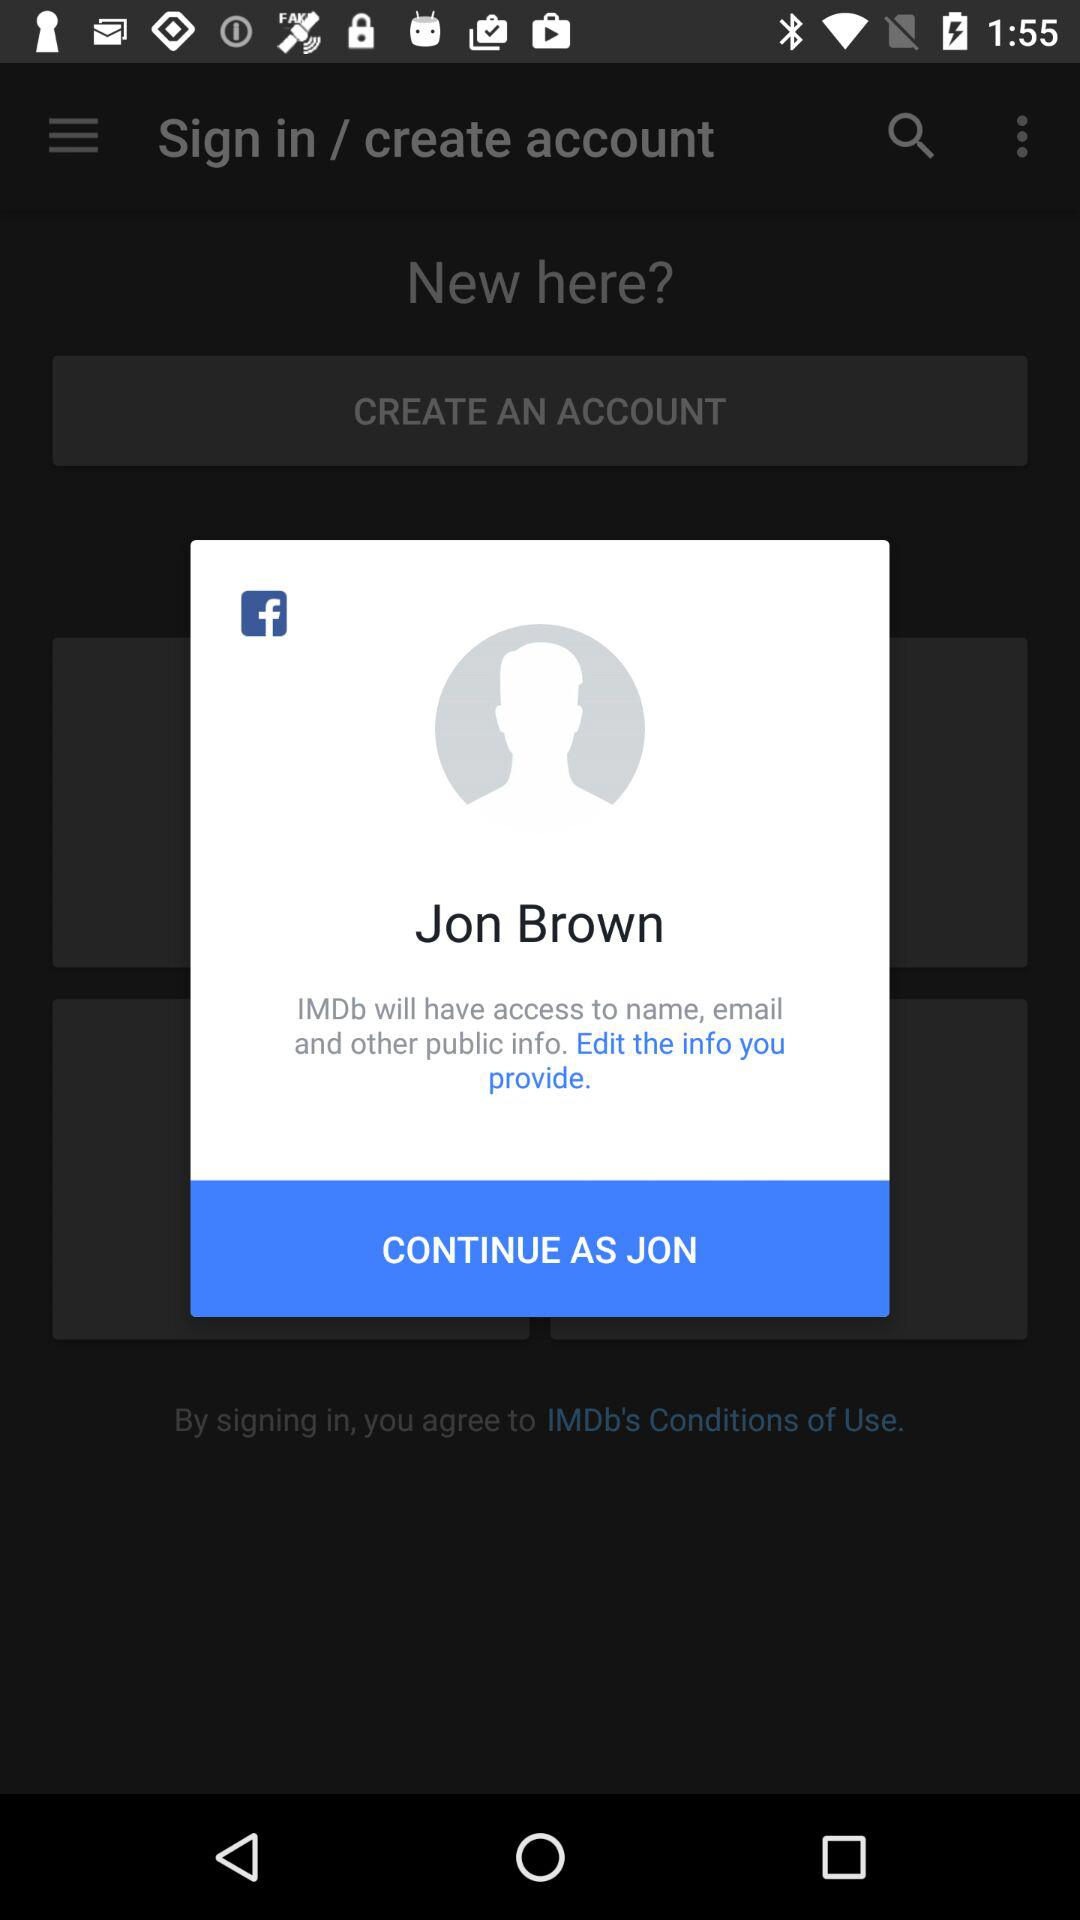How many public information items are IMDb allowed to access?
Answer the question using a single word or phrase. 3 